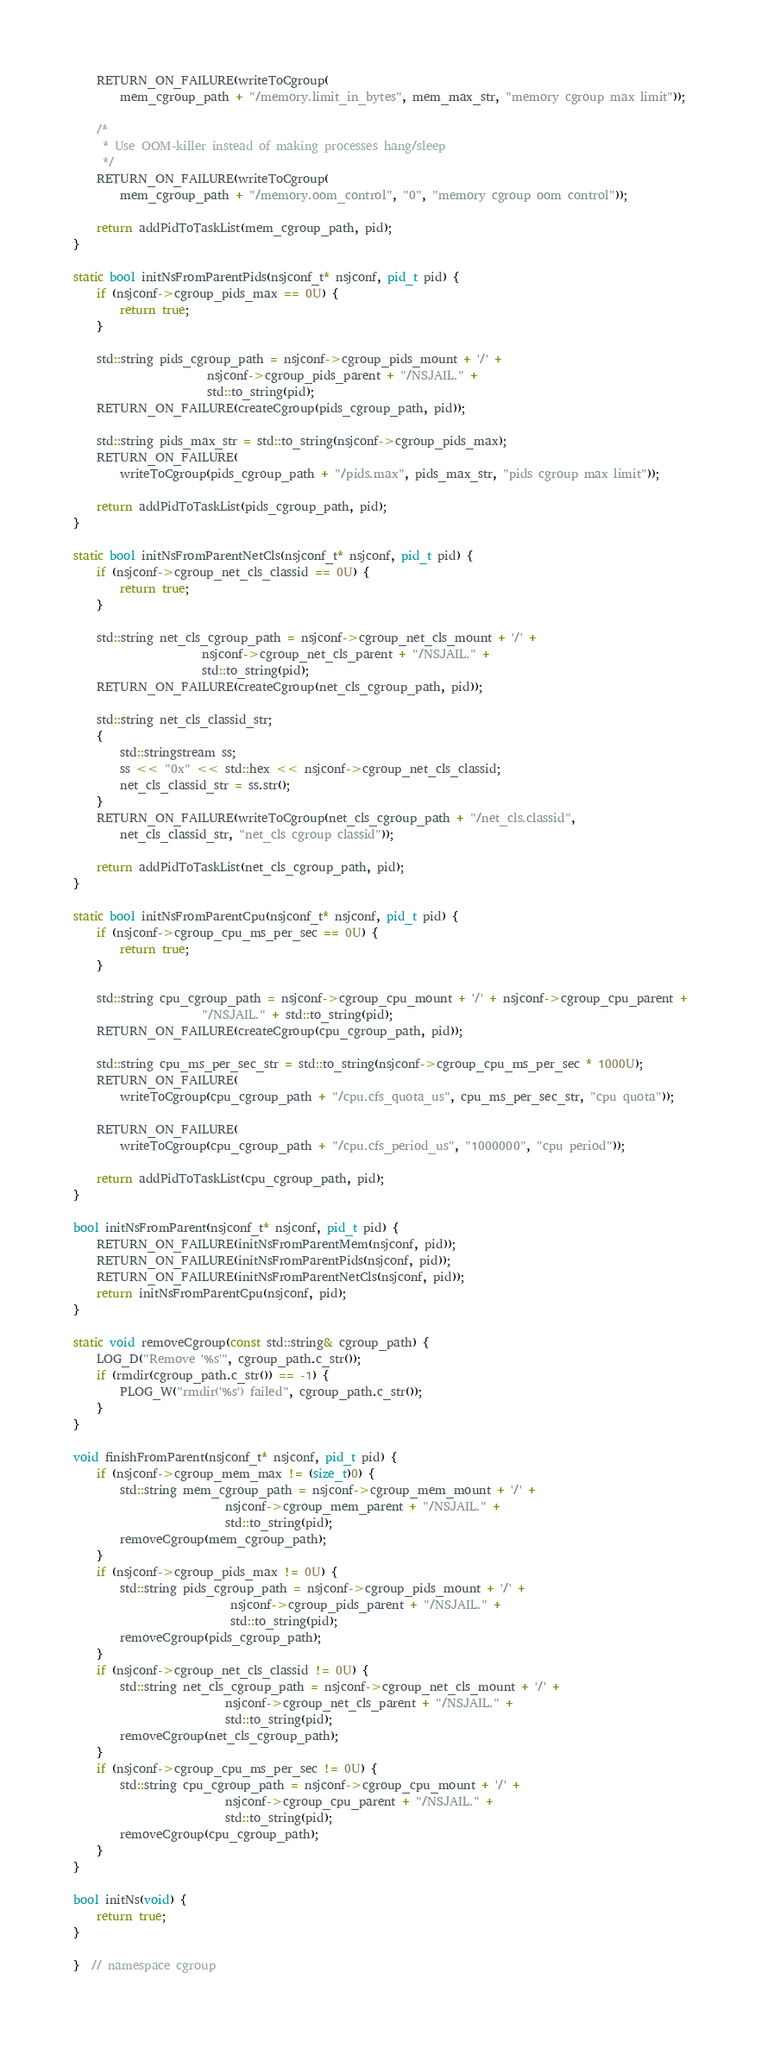<code> <loc_0><loc_0><loc_500><loc_500><_C++_>	RETURN_ON_FAILURE(writeToCgroup(
	    mem_cgroup_path + "/memory.limit_in_bytes", mem_max_str, "memory cgroup max limit"));

	/*
	 * Use OOM-killer instead of making processes hang/sleep
	 */
	RETURN_ON_FAILURE(writeToCgroup(
	    mem_cgroup_path + "/memory.oom_control", "0", "memory cgroup oom control"));

	return addPidToTaskList(mem_cgroup_path, pid);
}

static bool initNsFromParentPids(nsjconf_t* nsjconf, pid_t pid) {
	if (nsjconf->cgroup_pids_max == 0U) {
		return true;
	}

	std::string pids_cgroup_path = nsjconf->cgroup_pids_mount + '/' +
				       nsjconf->cgroup_pids_parent + "/NSJAIL." +
				       std::to_string(pid);
	RETURN_ON_FAILURE(createCgroup(pids_cgroup_path, pid));

	std::string pids_max_str = std::to_string(nsjconf->cgroup_pids_max);
	RETURN_ON_FAILURE(
	    writeToCgroup(pids_cgroup_path + "/pids.max", pids_max_str, "pids cgroup max limit"));

	return addPidToTaskList(pids_cgroup_path, pid);
}

static bool initNsFromParentNetCls(nsjconf_t* nsjconf, pid_t pid) {
	if (nsjconf->cgroup_net_cls_classid == 0U) {
		return true;
	}

	std::string net_cls_cgroup_path = nsjconf->cgroup_net_cls_mount + '/' +
					  nsjconf->cgroup_net_cls_parent + "/NSJAIL." +
					  std::to_string(pid);
	RETURN_ON_FAILURE(createCgroup(net_cls_cgroup_path, pid));

	std::string net_cls_classid_str;
	{
		std::stringstream ss;
		ss << "0x" << std::hex << nsjconf->cgroup_net_cls_classid;
		net_cls_classid_str = ss.str();
	}
	RETURN_ON_FAILURE(writeToCgroup(net_cls_cgroup_path + "/net_cls.classid",
	    net_cls_classid_str, "net_cls cgroup classid"));

	return addPidToTaskList(net_cls_cgroup_path, pid);
}

static bool initNsFromParentCpu(nsjconf_t* nsjconf, pid_t pid) {
	if (nsjconf->cgroup_cpu_ms_per_sec == 0U) {
		return true;
	}

	std::string cpu_cgroup_path = nsjconf->cgroup_cpu_mount + '/' + nsjconf->cgroup_cpu_parent +
				      "/NSJAIL." + std::to_string(pid);
	RETURN_ON_FAILURE(createCgroup(cpu_cgroup_path, pid));

	std::string cpu_ms_per_sec_str = std::to_string(nsjconf->cgroup_cpu_ms_per_sec * 1000U);
	RETURN_ON_FAILURE(
	    writeToCgroup(cpu_cgroup_path + "/cpu.cfs_quota_us", cpu_ms_per_sec_str, "cpu quota"));

	RETURN_ON_FAILURE(
	    writeToCgroup(cpu_cgroup_path + "/cpu.cfs_period_us", "1000000", "cpu period"));

	return addPidToTaskList(cpu_cgroup_path, pid);
}

bool initNsFromParent(nsjconf_t* nsjconf, pid_t pid) {
	RETURN_ON_FAILURE(initNsFromParentMem(nsjconf, pid));
	RETURN_ON_FAILURE(initNsFromParentPids(nsjconf, pid));
	RETURN_ON_FAILURE(initNsFromParentNetCls(nsjconf, pid));
	return initNsFromParentCpu(nsjconf, pid);
}

static void removeCgroup(const std::string& cgroup_path) {
	LOG_D("Remove '%s'", cgroup_path.c_str());
	if (rmdir(cgroup_path.c_str()) == -1) {
		PLOG_W("rmdir('%s') failed", cgroup_path.c_str());
	}
}

void finishFromParent(nsjconf_t* nsjconf, pid_t pid) {
	if (nsjconf->cgroup_mem_max != (size_t)0) {
		std::string mem_cgroup_path = nsjconf->cgroup_mem_mount + '/' +
					      nsjconf->cgroup_mem_parent + "/NSJAIL." +
					      std::to_string(pid);
		removeCgroup(mem_cgroup_path);
	}
	if (nsjconf->cgroup_pids_max != 0U) {
		std::string pids_cgroup_path = nsjconf->cgroup_pids_mount + '/' +
					       nsjconf->cgroup_pids_parent + "/NSJAIL." +
					       std::to_string(pid);
		removeCgroup(pids_cgroup_path);
	}
	if (nsjconf->cgroup_net_cls_classid != 0U) {
		std::string net_cls_cgroup_path = nsjconf->cgroup_net_cls_mount + '/' +
						  nsjconf->cgroup_net_cls_parent + "/NSJAIL." +
						  std::to_string(pid);
		removeCgroup(net_cls_cgroup_path);
	}
	if (nsjconf->cgroup_cpu_ms_per_sec != 0U) {
		std::string cpu_cgroup_path = nsjconf->cgroup_cpu_mount + '/' +
					      nsjconf->cgroup_cpu_parent + "/NSJAIL." +
					      std::to_string(pid);
		removeCgroup(cpu_cgroup_path);
	}
}

bool initNs(void) {
	return true;
}

}  // namespace cgroup
</code> 